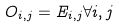<formula> <loc_0><loc_0><loc_500><loc_500>O _ { i , j } = E _ { i , j } \forall i , j</formula> 